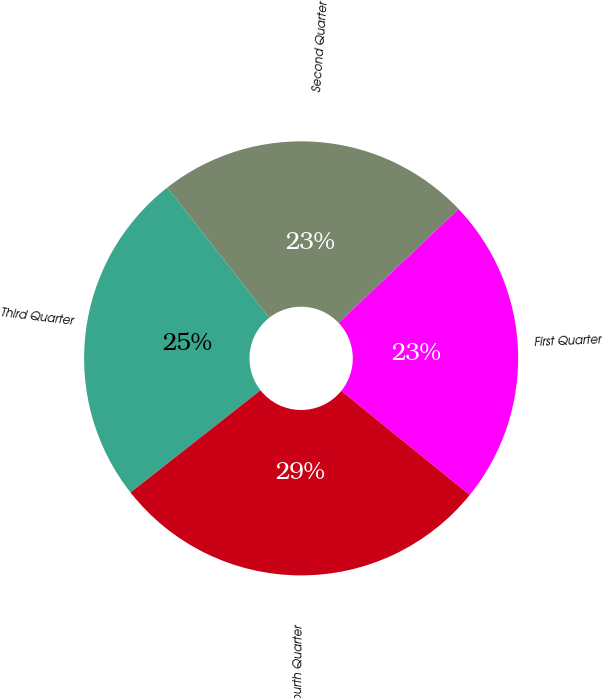Convert chart to OTSL. <chart><loc_0><loc_0><loc_500><loc_500><pie_chart><fcel>First Quarter<fcel>Second Quarter<fcel>Third Quarter<fcel>Fourth Quarter<nl><fcel>22.92%<fcel>23.49%<fcel>25.02%<fcel>28.56%<nl></chart> 